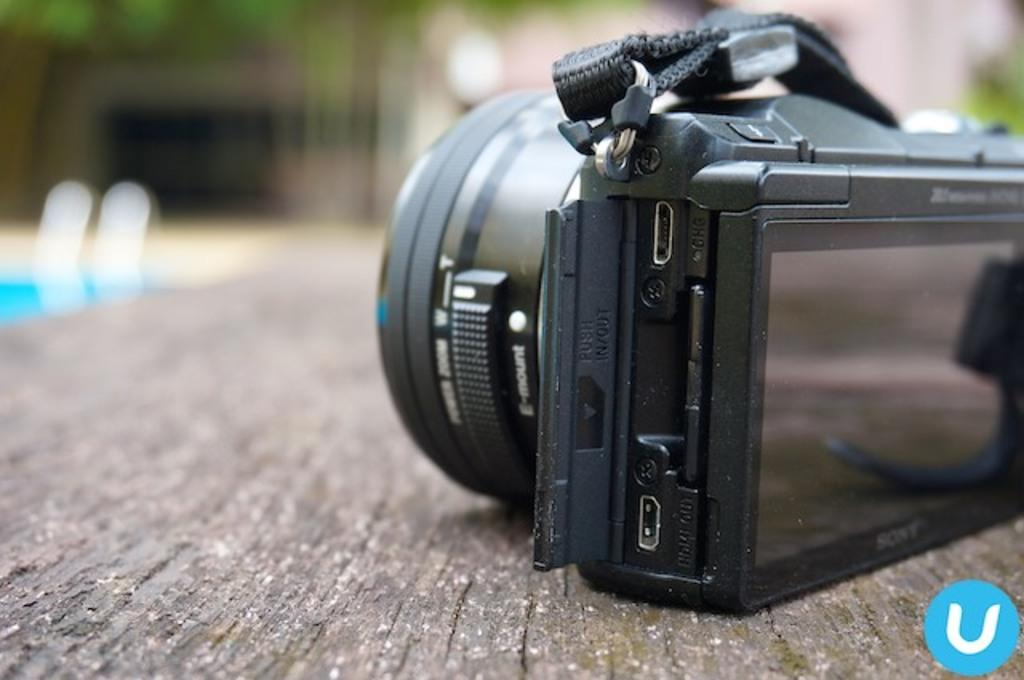What is the main object in the front of the image? There is a camera in the front of the image. What can be seen in the distance behind the camera? There are buildings in the background of the image. How would you describe the appearance of the background? The background is slightly blurred. What invention is being plotted in the image? There is no invention or plot depicted in the image; it simply shows a camera and buildings in the background. 